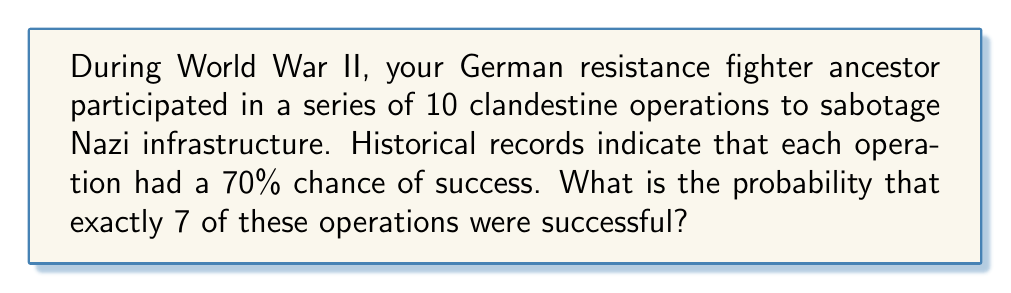Can you answer this question? To solve this problem, we'll use the binomial distribution. The binomial distribution is used when we have a fixed number of independent trials, each with the same probability of success.

Let's define our variables:
$n = 10$ (total number of operations)
$k = 7$ (number of successful operations we're interested in)
$p = 0.70$ (probability of success for each operation)

The binomial probability formula is:

$$P(X = k) = \binom{n}{k} p^k (1-p)^{n-k}$$

Where $\binom{n}{k}$ is the binomial coefficient, calculated as:

$$\binom{n}{k} = \frac{n!}{k!(n-k)!}$$

Let's solve step by step:

1) Calculate the binomial coefficient:
   $$\binom{10}{7} = \frac{10!}{7!(10-7)!} = \frac{10!}{7!3!} = 120$$

2) Calculate $p^k$:
   $0.70^7 \approx 0.0824$

3) Calculate $(1-p)^{n-k}$:
   $(1-0.70)^{10-7} = 0.30^3 \approx 0.027$

4) Put it all together in the binomial probability formula:
   $$P(X = 7) = 120 \times 0.0824 \times 0.027 \approx 0.2668$$

Therefore, the probability of exactly 7 successful operations out of 10 is approximately 0.2668 or 26.68%.
Answer: 0.2668 or 26.68% 